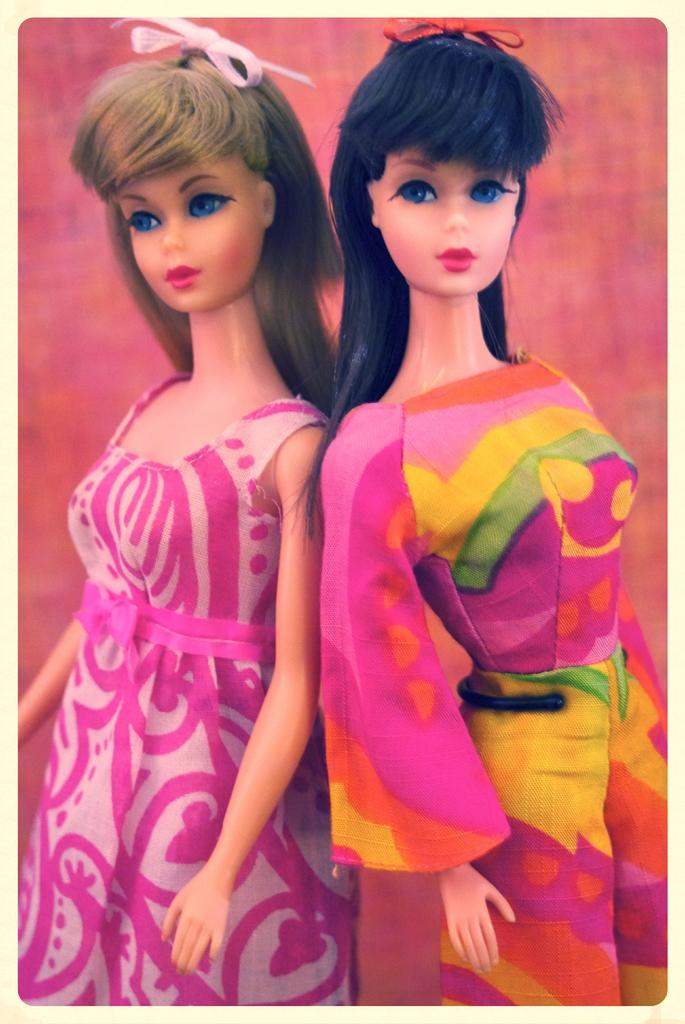How many dolls are present in the image? There are two dolls in the image. What are the dolls wearing? The dolls are wearing dresses. What color is the background of the image? The background of the image is pink. Can you see a person playing with a kitten in the yard in the image? There is no person or kitten present in the image, and it does not depict a yard. 